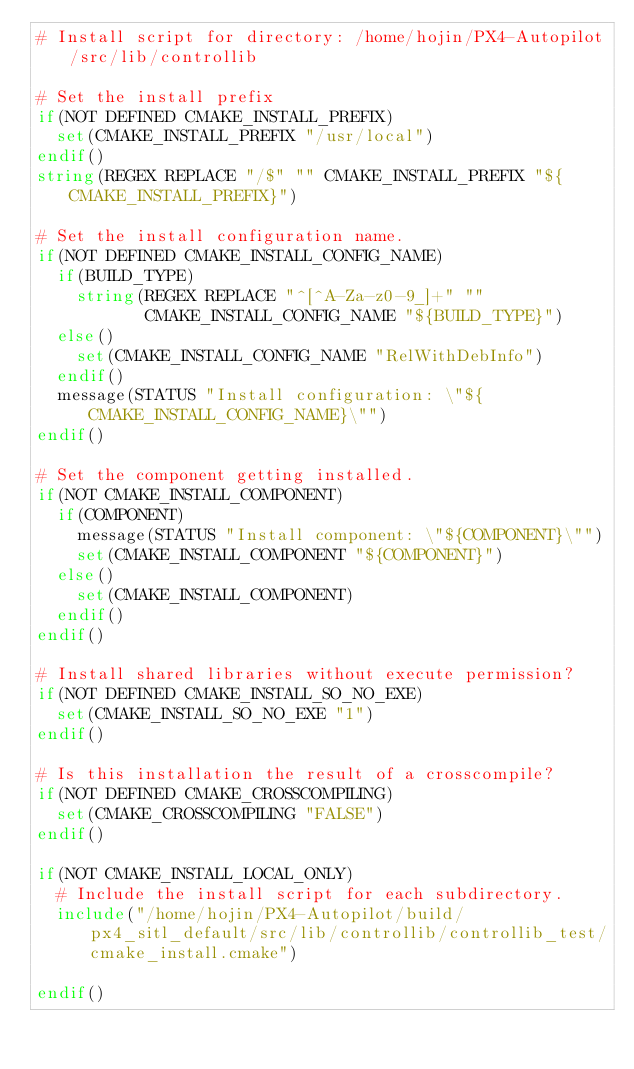<code> <loc_0><loc_0><loc_500><loc_500><_CMake_># Install script for directory: /home/hojin/PX4-Autopilot/src/lib/controllib

# Set the install prefix
if(NOT DEFINED CMAKE_INSTALL_PREFIX)
  set(CMAKE_INSTALL_PREFIX "/usr/local")
endif()
string(REGEX REPLACE "/$" "" CMAKE_INSTALL_PREFIX "${CMAKE_INSTALL_PREFIX}")

# Set the install configuration name.
if(NOT DEFINED CMAKE_INSTALL_CONFIG_NAME)
  if(BUILD_TYPE)
    string(REGEX REPLACE "^[^A-Za-z0-9_]+" ""
           CMAKE_INSTALL_CONFIG_NAME "${BUILD_TYPE}")
  else()
    set(CMAKE_INSTALL_CONFIG_NAME "RelWithDebInfo")
  endif()
  message(STATUS "Install configuration: \"${CMAKE_INSTALL_CONFIG_NAME}\"")
endif()

# Set the component getting installed.
if(NOT CMAKE_INSTALL_COMPONENT)
  if(COMPONENT)
    message(STATUS "Install component: \"${COMPONENT}\"")
    set(CMAKE_INSTALL_COMPONENT "${COMPONENT}")
  else()
    set(CMAKE_INSTALL_COMPONENT)
  endif()
endif()

# Install shared libraries without execute permission?
if(NOT DEFINED CMAKE_INSTALL_SO_NO_EXE)
  set(CMAKE_INSTALL_SO_NO_EXE "1")
endif()

# Is this installation the result of a crosscompile?
if(NOT DEFINED CMAKE_CROSSCOMPILING)
  set(CMAKE_CROSSCOMPILING "FALSE")
endif()

if(NOT CMAKE_INSTALL_LOCAL_ONLY)
  # Include the install script for each subdirectory.
  include("/home/hojin/PX4-Autopilot/build/px4_sitl_default/src/lib/controllib/controllib_test/cmake_install.cmake")

endif()

</code> 